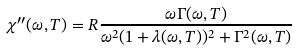<formula> <loc_0><loc_0><loc_500><loc_500>\chi ^ { \prime \prime } ( \omega , T ) = R \frac { \omega \Gamma ( \omega , T ) } { \omega ^ { 2 } ( 1 + \lambda ( \omega , T ) ) ^ { 2 } + \Gamma ^ { 2 } ( \omega , T ) }</formula> 